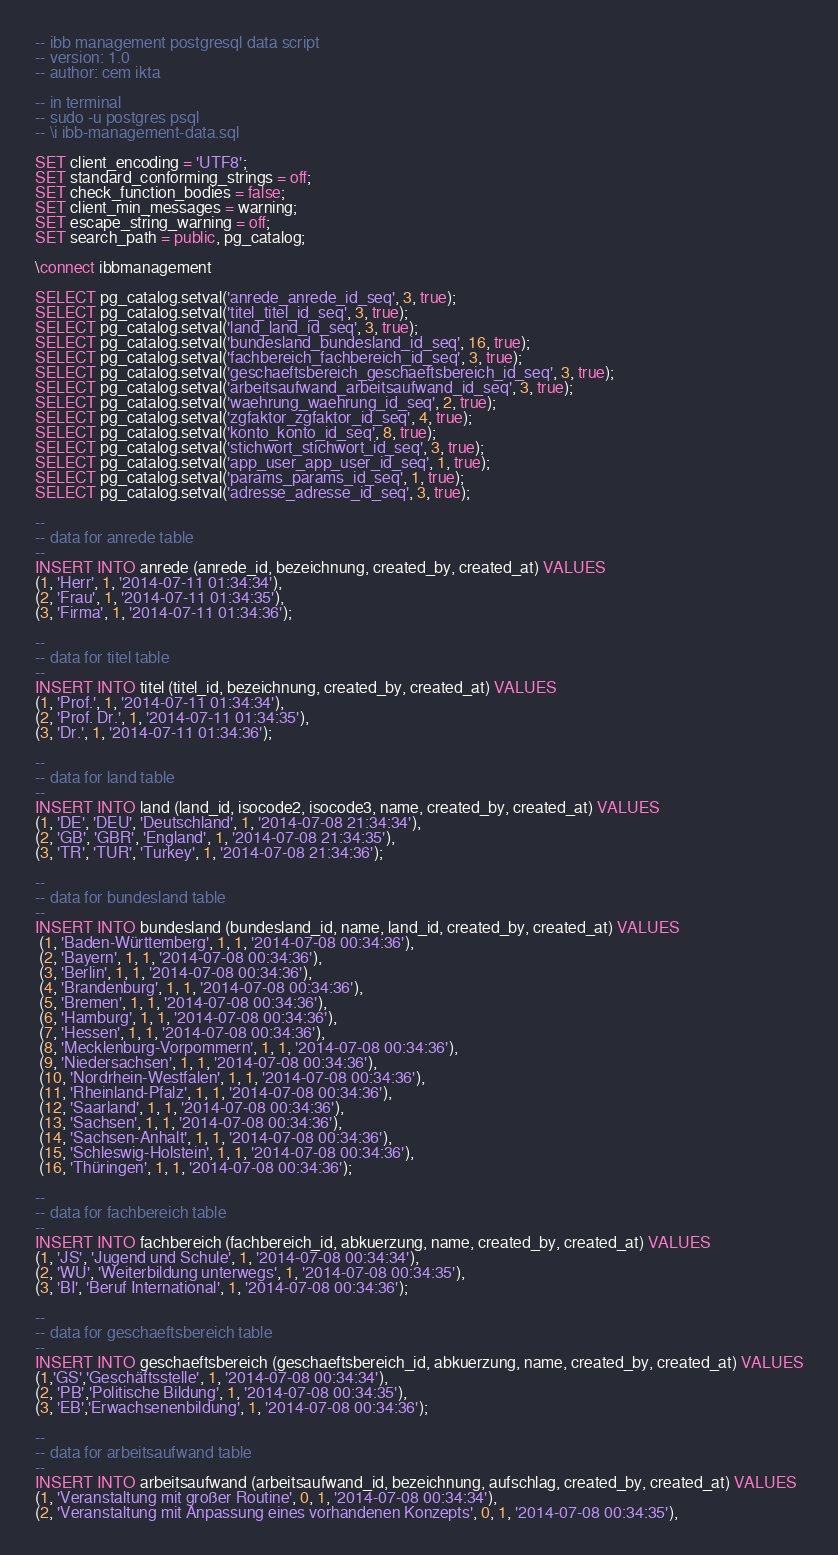Convert code to text. <code><loc_0><loc_0><loc_500><loc_500><_SQL_>-- ibb management postgresql data script
-- version: 1.0
-- author: cem ikta

-- in terminal
-- sudo -u postgres psql
-- \i ibb-management-data.sql

SET client_encoding = 'UTF8';
SET standard_conforming_strings = off;
SET check_function_bodies = false;
SET client_min_messages = warning;
SET escape_string_warning = off;
SET search_path = public, pg_catalog;

\connect ibbmanagement

SELECT pg_catalog.setval('anrede_anrede_id_seq', 3, true);
SELECT pg_catalog.setval('titel_titel_id_seq', 3, true);
SELECT pg_catalog.setval('land_land_id_seq', 3, true);
SELECT pg_catalog.setval('bundesland_bundesland_id_seq', 16, true);
SELECT pg_catalog.setval('fachbereich_fachbereich_id_seq', 3, true);
SELECT pg_catalog.setval('geschaeftsbereich_geschaeftsbereich_id_seq', 3, true);
SELECT pg_catalog.setval('arbeitsaufwand_arbeitsaufwand_id_seq', 3, true);
SELECT pg_catalog.setval('waehrung_waehrung_id_seq', 2, true);
SELECT pg_catalog.setval('zgfaktor_zgfaktor_id_seq', 4, true);
SELECT pg_catalog.setval('konto_konto_id_seq', 8, true);
SELECT pg_catalog.setval('stichwort_stichwort_id_seq', 3, true);
SELECT pg_catalog.setval('app_user_app_user_id_seq', 1, true);
SELECT pg_catalog.setval('params_params_id_seq', 1, true);
SELECT pg_catalog.setval('adresse_adresse_id_seq', 3, true);

--
-- data for anrede table
--
INSERT INTO anrede (anrede_id, bezeichnung, created_by, created_at) VALUES 
(1, 'Herr', 1, '2014-07-11 01:34:34'),
(2, 'Frau', 1, '2014-07-11 01:34:35'),
(3, 'Firma', 1, '2014-07-11 01:34:36');

--
-- data for titel table
--
INSERT INTO titel (titel_id, bezeichnung, created_by, created_at) VALUES 
(1, 'Prof.', 1, '2014-07-11 01:34:34'),
(2, 'Prof. Dr.', 1, '2014-07-11 01:34:35'),
(3, 'Dr.', 1, '2014-07-11 01:34:36');

--
-- data for land table
--
INSERT INTO land (land_id, isocode2, isocode3, name, created_by, created_at) VALUES 
(1, 'DE', 'DEU', 'Deutschland', 1, '2014-07-08 21:34:34'),
(2, 'GB', 'GBR', 'England', 1, '2014-07-08 21:34:35'),
(3, 'TR', 'TUR', 'Turkey', 1, '2014-07-08 21:34:36');

--
-- data for bundesland table
--
INSERT INTO bundesland (bundesland_id, name, land_id, created_by, created_at) VALUES 
 (1, 'Baden-Württemberg', 1, 1, '2014-07-08 00:34:36'),
 (2, 'Bayern', 1, 1, '2014-07-08 00:34:36'),
 (3, 'Berlin', 1, 1, '2014-07-08 00:34:36'),
 (4, 'Brandenburg', 1, 1, '2014-07-08 00:34:36'),
 (5, 'Bremen', 1, 1, '2014-07-08 00:34:36'),
 (6, 'Hamburg', 1, 1, '2014-07-08 00:34:36'),
 (7, 'Hessen', 1, 1, '2014-07-08 00:34:36'),
 (8, 'Mecklenburg-Vorpommern', 1, 1, '2014-07-08 00:34:36'),
 (9, 'Niedersachsen', 1, 1, '2014-07-08 00:34:36'),
 (10, 'Nordrhein-Westfalen', 1, 1, '2014-07-08 00:34:36'),
 (11, 'Rheinland-Pfalz', 1, 1, '2014-07-08 00:34:36'),
 (12, 'Saarland', 1, 1, '2014-07-08 00:34:36'),
 (13, 'Sachsen', 1, 1, '2014-07-08 00:34:36'),
 (14, 'Sachsen-Anhalt', 1, 1, '2014-07-08 00:34:36'),
 (15, 'Schleswig-Holstein', 1, 1, '2014-07-08 00:34:36'),
 (16, 'Thüringen', 1, 1, '2014-07-08 00:34:36');

--
-- data for fachbereich table
--
INSERT INTO fachbereich (fachbereich_id, abkuerzung, name, created_by, created_at) VALUES
(1, 'JS', 'Jugend und Schule', 1, '2014-07-08 00:34:34'),
(2, 'WU', 'Weiterbildung unterwegs', 1, '2014-07-08 00:34:35'),
(3, 'BI', 'Beruf International', 1, '2014-07-08 00:34:36');

--
-- data for geschaeftsbereich table
--
INSERT INTO geschaeftsbereich (geschaeftsbereich_id, abkuerzung, name, created_by, created_at) VALUES
(1,'GS','Geschäftsstelle', 1, '2014-07-08 00:34:34'),
(2, 'PB','Politische Bildung', 1, '2014-07-08 00:34:35'),
(3, 'EB','Erwachsenenbildung', 1, '2014-07-08 00:34:36');

--
-- data for arbeitsaufwand table
--
INSERT INTO arbeitsaufwand (arbeitsaufwand_id, bezeichnung, aufschlag, created_by, created_at) VALUES 
(1, 'Veranstaltung mit großer Routine', 0, 1, '2014-07-08 00:34:34'),
(2, 'Veranstaltung mit Anpassung eines vorhandenen Konzepts', 0, 1, '2014-07-08 00:34:35'),</code> 